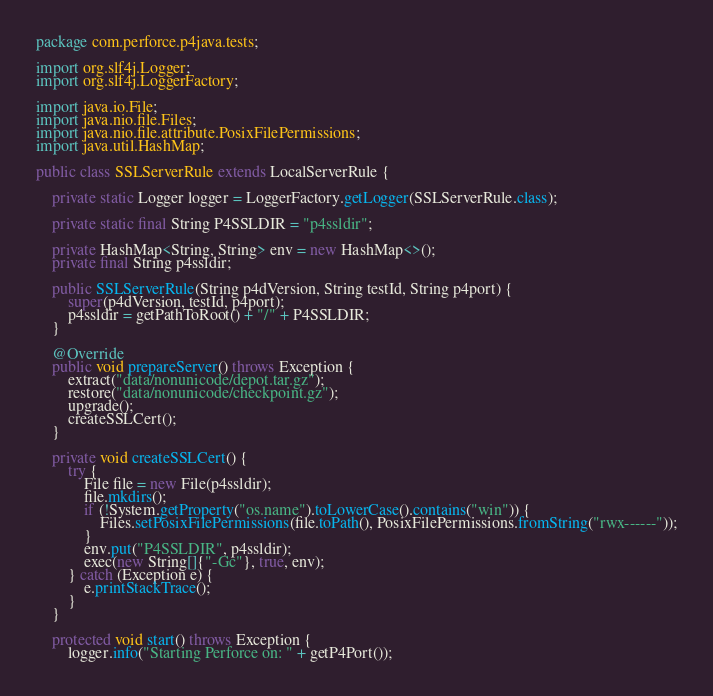Convert code to text. <code><loc_0><loc_0><loc_500><loc_500><_Java_>package com.perforce.p4java.tests;

import org.slf4j.Logger;
import org.slf4j.LoggerFactory;

import java.io.File;
import java.nio.file.Files;
import java.nio.file.attribute.PosixFilePermissions;
import java.util.HashMap;

public class SSLServerRule extends LocalServerRule {

	private static Logger logger = LoggerFactory.getLogger(SSLServerRule.class);

	private static final String P4SSLDIR = "p4ssldir";

	private HashMap<String, String> env = new HashMap<>();
	private final String p4ssldir;

	public SSLServerRule(String p4dVersion, String testId, String p4port) {
		super(p4dVersion, testId, p4port);
		p4ssldir = getPathToRoot() + "/" + P4SSLDIR;
	}

	@Override
	public void prepareServer() throws Exception {
		extract("data/nonunicode/depot.tar.gz");
		restore("data/nonunicode/checkpoint.gz");
		upgrade();
		createSSLCert();
	}

	private void createSSLCert() {
		try {
			File file = new File(p4ssldir);
			file.mkdirs();
			if (!System.getProperty("os.name").toLowerCase().contains("win")) {
				Files.setPosixFilePermissions(file.toPath(), PosixFilePermissions.fromString("rwx------"));
			}
			env.put("P4SSLDIR", p4ssldir);
			exec(new String[]{"-Gc"}, true, env);
		} catch (Exception e) {
			e.printStackTrace();
		}
	}

	protected void start() throws Exception {
		logger.info("Starting Perforce on: " + getP4Port());</code> 